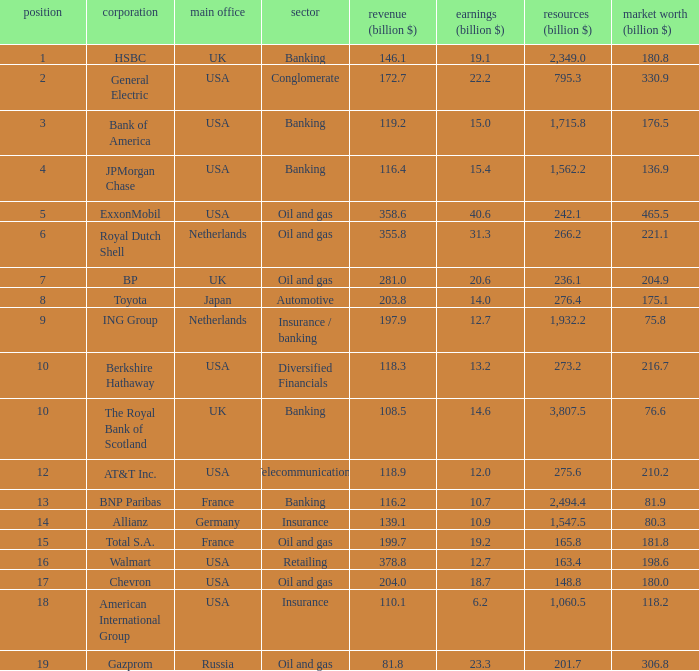What is the market value of a company in billions that has 172.7 billion in sales?  330.9. 